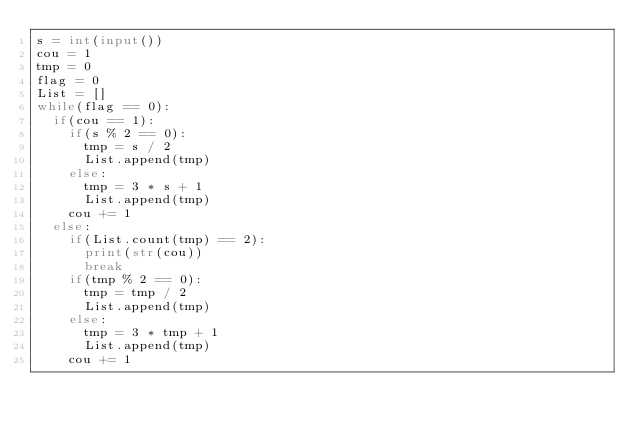Convert code to text. <code><loc_0><loc_0><loc_500><loc_500><_Python_>s = int(input())
cou = 1
tmp = 0
flag = 0
List = []
while(flag == 0):
  if(cou == 1):
    if(s % 2 == 0):
      tmp = s / 2
      List.append(tmp)
    else:
      tmp = 3 * s + 1
      List.append(tmp)
    cou += 1
  else:
    if(List.count(tmp) == 2):
      print(str(cou))
      break
    if(tmp % 2 == 0):
      tmp = tmp / 2
      List.append(tmp)
    else:
      tmp = 3 * tmp + 1
      List.append(tmp)
    cou += 1</code> 